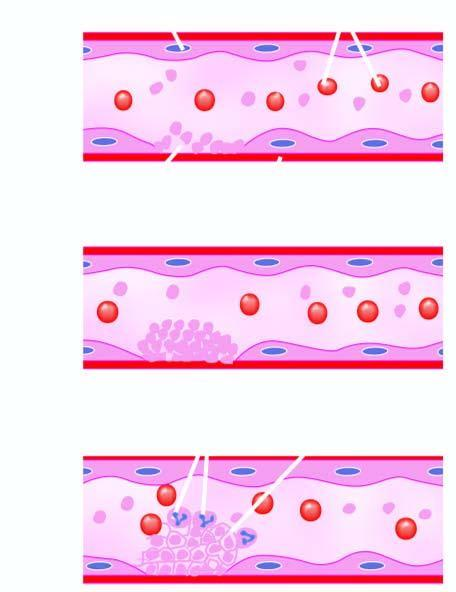what is released which causes further aggregation of platelets following platelet release reaction?
Answer the question using a single word or phrase. Adp 